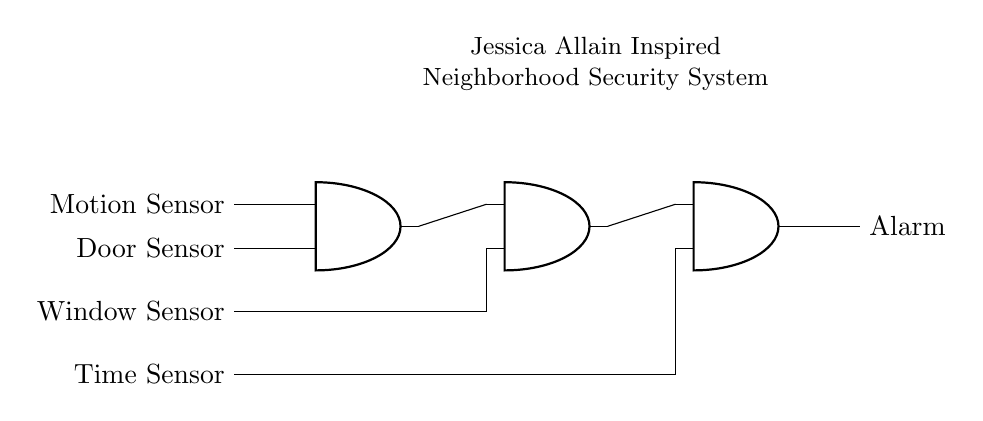What is the final output of the circuit? The output of the AND gate is labeled as 'Alarm', which indicates the action taken by the circuit when certain conditions are met.
Answer: Alarm How many AND gates are present in the circuit? By counting the symbols marked as AND gates in the diagram, there are three AND gates shown, each performing a logical operation.
Answer: Three What sensors are connected to the first AND gate? The first AND gate receives inputs from a 'Motion Sensor' and a 'Door Sensor', as indicated in the diagram with arrows pointing to each sensor.
Answer: Motion Sensor, Door Sensor What sensor is connected to the second AND gate? The second AND gate has its inputs from the output of the first AND gate and a 'Window Sensor', with the connections clearly marked in the diagram.
Answer: Window Sensor What conditions must be met for the alarm to trigger? All sensors connected to the series of AND gates must be activated for the alarm to go off; hence, a logical product of all inputs is required.
Answer: All sensors activated What is the role of the 'Time Sensor' in this circuit? The 'Time Sensor' is connected to the last AND gate, implying that it provides an additional condition that must also be satisfied for the alarm to activate.
Answer: Provides additional condition Which gate receives input from another gate? The second AND gate receives its input from the output of the first AND gate, thus indicating a dependency among the gates.
Answer: Second AND gate 